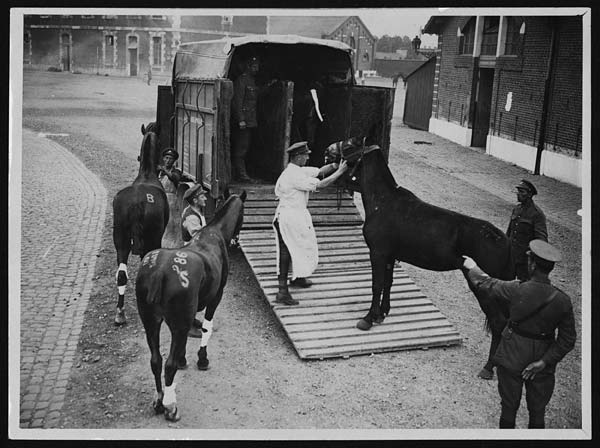<image>What is the marking on the horse's flank called? I don't know what the marking on the horse's flank is called. It could be a brand, a flank spot, or others. What is the marking on the horse's flank called? I am not sure what the marking on the horse's flank is called. It can be a brand, a flank spot, or something else. 